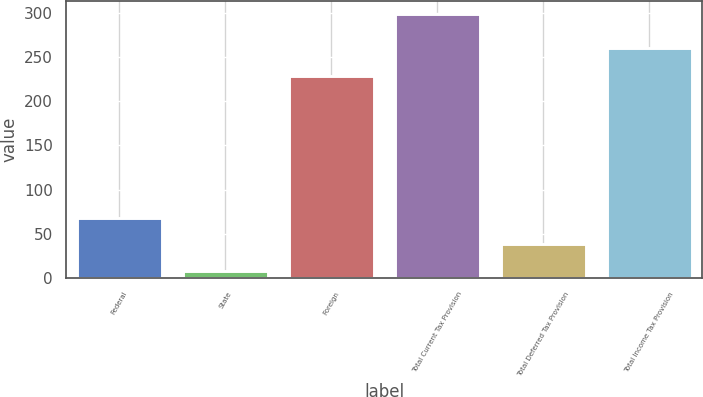Convert chart. <chart><loc_0><loc_0><loc_500><loc_500><bar_chart><fcel>Federal<fcel>State<fcel>Foreign<fcel>Total Current Tax Provision<fcel>Total Deferred Tax Provision<fcel>Total Income Tax Provision<nl><fcel>67.19<fcel>7<fcel>229.1<fcel>298.9<fcel>38<fcel>260.9<nl></chart> 